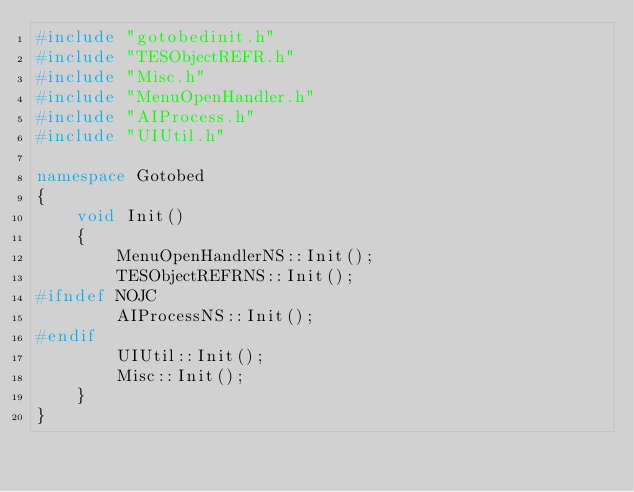Convert code to text. <code><loc_0><loc_0><loc_500><loc_500><_C++_>#include "gotobedinit.h"
#include "TESObjectREFR.h"
#include "Misc.h"
#include "MenuOpenHandler.h"
#include "AIProcess.h"
#include "UIUtil.h"

namespace Gotobed
{
	void Init()
	{
		MenuOpenHandlerNS::Init();
		TESObjectREFRNS::Init();
#ifndef NOJC
		AIProcessNS::Init();
#endif
		UIUtil::Init();
		Misc::Init();
	}
}</code> 